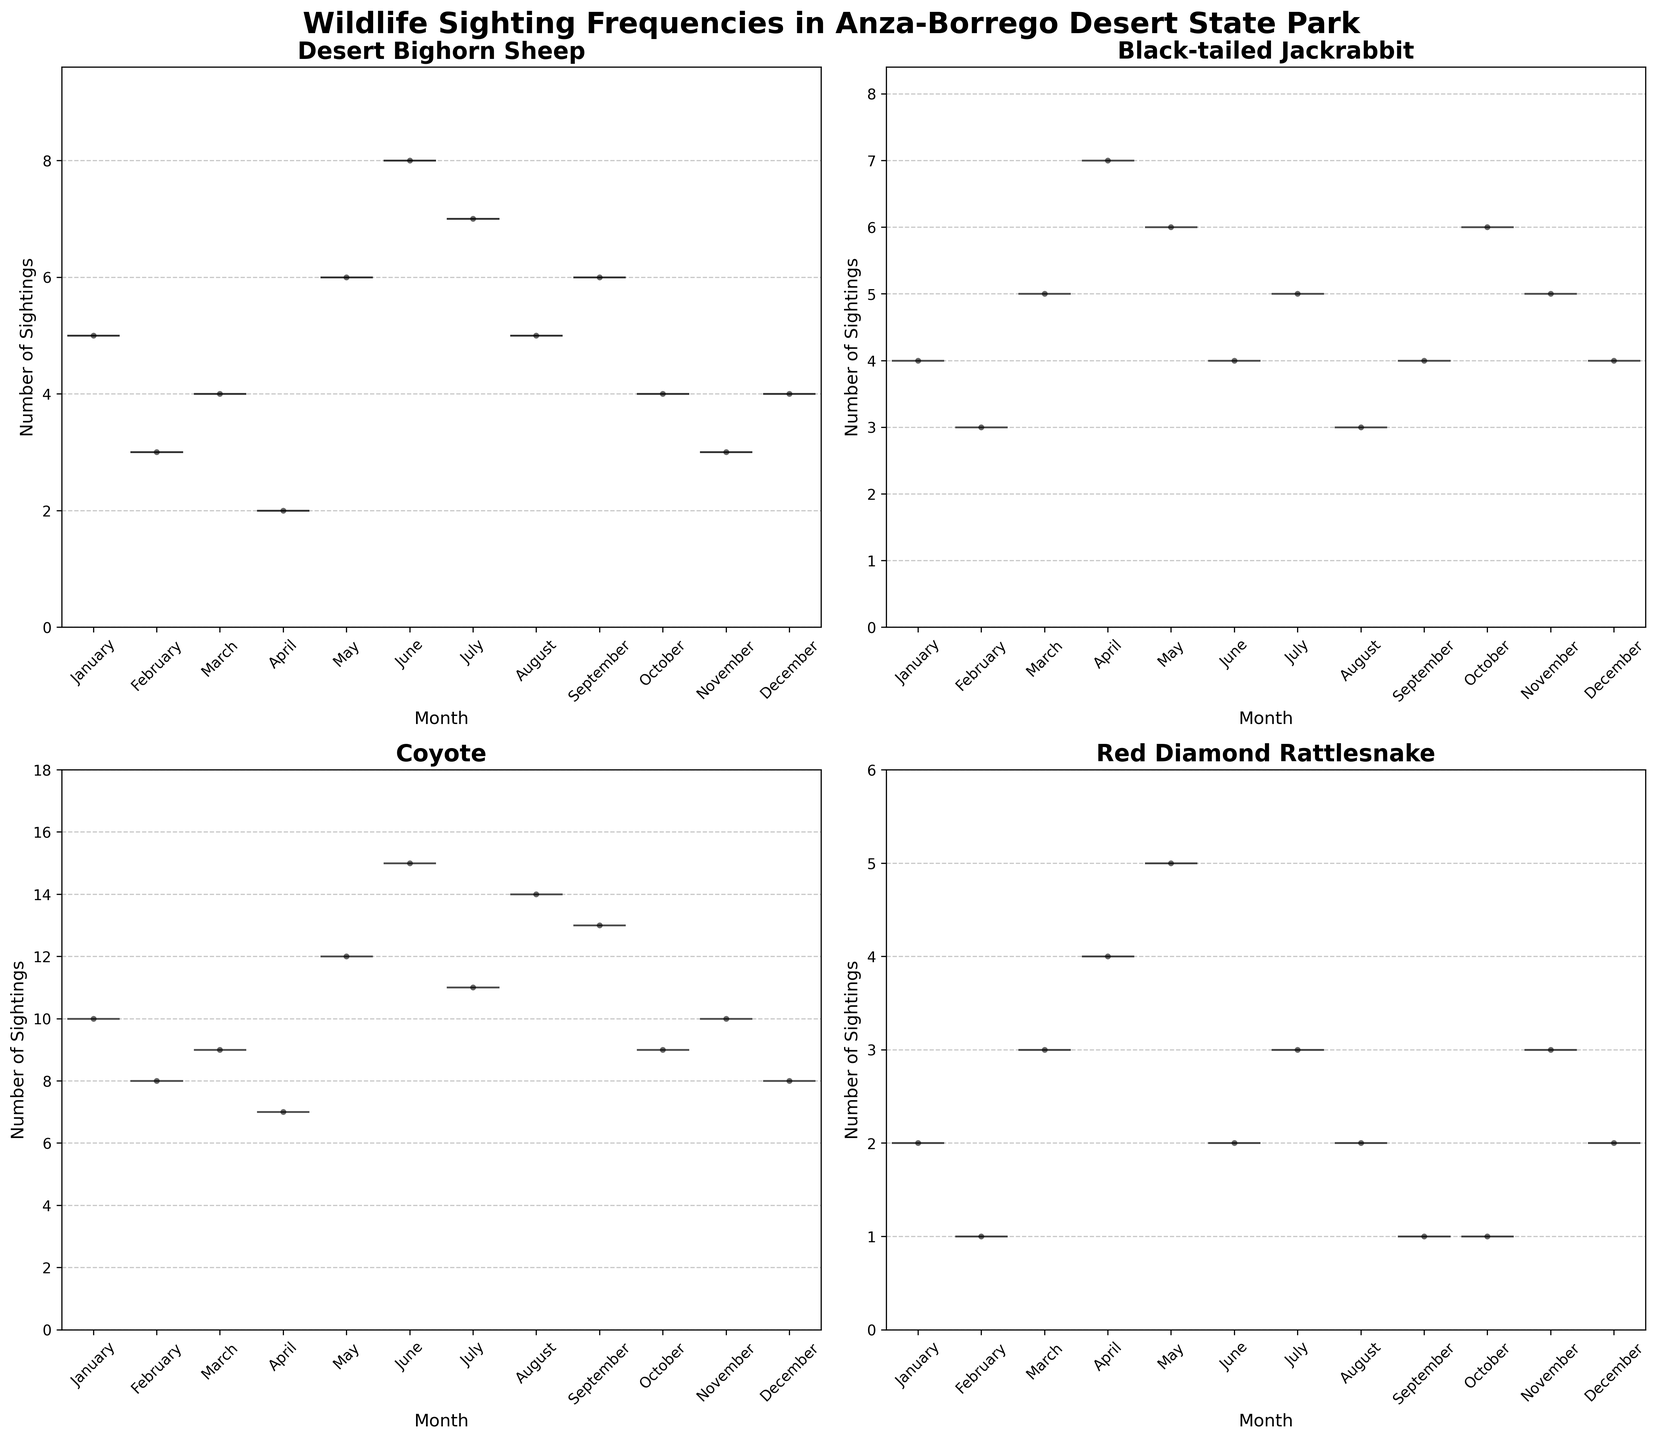Which species is sighted the least in January? The violin plots show the median and distribution of sightings. By looking at January, you can see that Red Diamond Rattlesnake has the fewest sightings compared to the other species.
Answer: Red Diamond Rattlesnake Which month has the highest median number of sightings for Coyotes? By checking the violin plot for Coyotes, observe which month has the highest center box (most raised) inside the violin. The highest median occurs in June.
Answer: June How does the median sightings of Desert Bighorn Sheep in June compare to that in February? Look at the center lines on the Desert Bighorn Sheep's violin plots for June and February. The line for June is higher, indicating a higher median value.
Answer: Higher in June Which species shows the most consistent number of sightings across all months? Look for the species with the narrowest and least variable violin shapes, indicating little distribution spread. Red Diamond Rattlesnake shows the most consistent sightings.
Answer: Red Diamond Rattlesnake How many species have at least one month with more than 10 sightings? Check each violin plot for months where the upper extent surpasses 10 sightings. Coyote is the only species with more than 10 sightings in at least one month.
Answer: 1 species (Coyote) Which month has the highest range of sightings for Black-tailed Jackrabbit? Examine the Black-tailed Jackrabbit's violin plots to find the month where the distribution is the widest. April has the widest spread, indicating the highest range.
Answer: April In which month is Desert Bighorn Sheep's sighting frequency most similar to Red Diamond Rattlesnake's? Compare months for both species' violin plots to find where their plotted shapes and medians are similar. In August, both their distributions and medians are similar.
Answer: August Which species has the most variable sighting frequency throughout the year? Compare the width and spread of all species' violin plots to identify the one with the widest and most variable shapes. Coyotes show the most variable sighting frequency.
Answer: Coyotes Are there any species whose median sightings never drop to zero in any month? Look at the center lines (medians) in the violin plots for each species and see if any ever touch zero. None of the species have medians that drop to zero in any month as seen by the position of the inner boxes.
Answer: No Based on the charts, which species likely has a peak sighting period in summer? Check the violin plots to see any species that have substantial medians or widest distributions in summer months (June-August). Coyotes have higher median sightings during these months.
Answer: Coyotes 